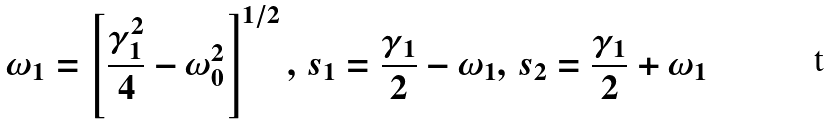Convert formula to latex. <formula><loc_0><loc_0><loc_500><loc_500>\omega _ { 1 } = \left [ \frac { \gamma _ { 1 } ^ { 2 } } { 4 } - \omega _ { 0 } ^ { 2 } \right ] ^ { 1 / 2 } , \, s _ { 1 } = \frac { \gamma _ { 1 } } { 2 } - \omega _ { 1 } , \, s _ { 2 } = \frac { \gamma _ { 1 } } { 2 } + \omega _ { 1 }</formula> 